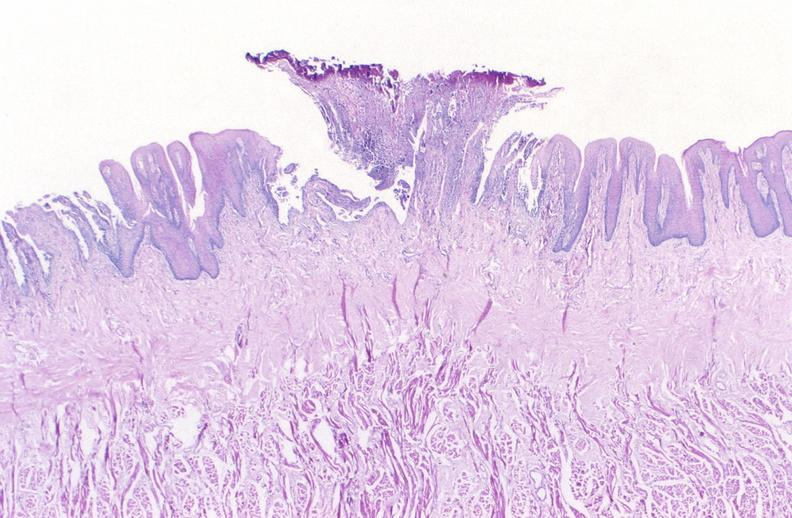what is present?
Answer the question using a single word or phrase. Gastrointestinal 